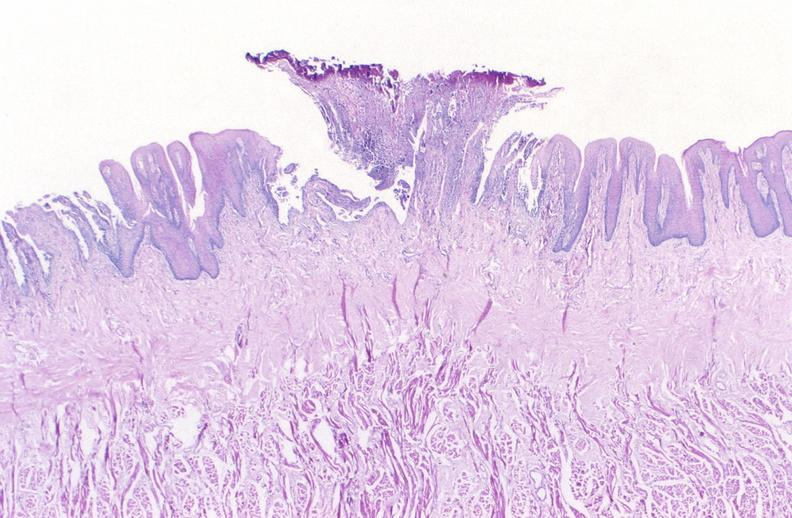what is present?
Answer the question using a single word or phrase. Gastrointestinal 